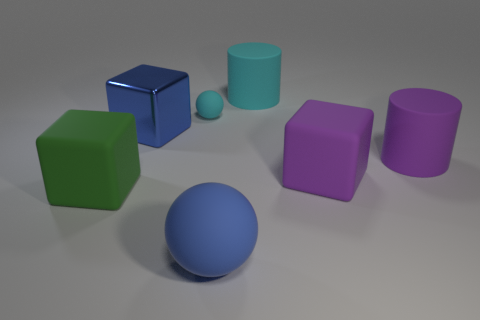Add 1 metallic objects. How many objects exist? 8 Subtract all cubes. How many objects are left? 4 Subtract 0 brown balls. How many objects are left? 7 Subtract all tiny brown rubber blocks. Subtract all green blocks. How many objects are left? 6 Add 6 big blue objects. How many big blue objects are left? 8 Add 5 rubber cubes. How many rubber cubes exist? 7 